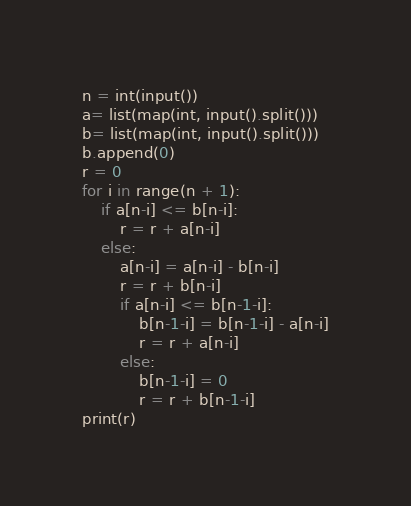Convert code to text. <code><loc_0><loc_0><loc_500><loc_500><_Python_>n = int(input())
a= list(map(int, input().split()))
b= list(map(int, input().split()))
b.append(0)
r = 0
for i in range(n + 1):
    if a[n-i] <= b[n-i]:
        r = r + a[n-i]
    else:
        a[n-i] = a[n-i] - b[n-i]
        r = r + b[n-i]
        if a[n-i] <= b[n-1-i]:
            b[n-1-i] = b[n-1-i] - a[n-i]
            r = r + a[n-i]
        else:
            b[n-1-i] = 0
            r = r + b[n-1-i]
print(r)</code> 